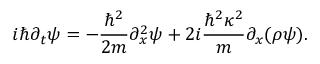<formula> <loc_0><loc_0><loc_500><loc_500>i \hbar { \partial } _ { t } \psi = - { \frac { \hbar { ^ } { 2 } } { 2 m } } \partial _ { x } ^ { 2 } \psi + 2 i { \frac { \hbar { ^ } { 2 } \kappa ^ { 2 } } { m } } \partial _ { x } ( \rho \psi ) .</formula> 